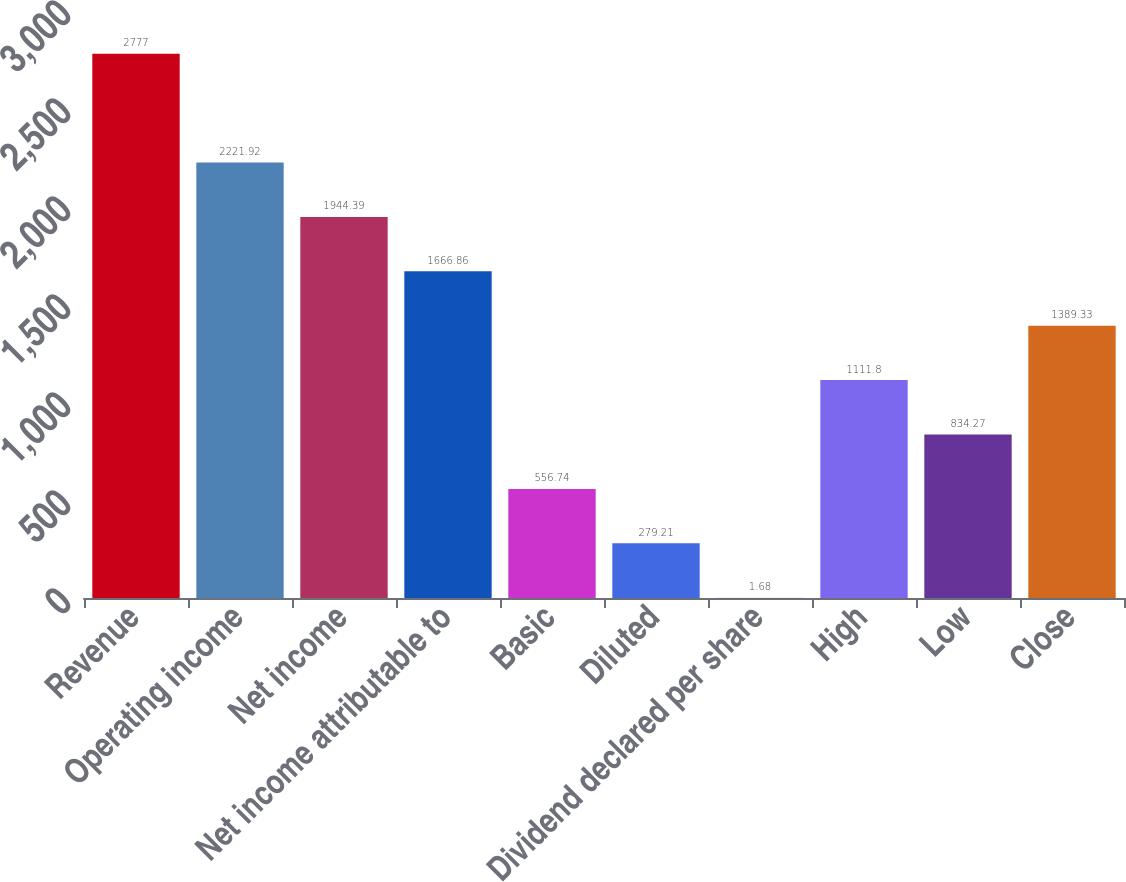Convert chart to OTSL. <chart><loc_0><loc_0><loc_500><loc_500><bar_chart><fcel>Revenue<fcel>Operating income<fcel>Net income<fcel>Net income attributable to<fcel>Basic<fcel>Diluted<fcel>Dividend declared per share<fcel>High<fcel>Low<fcel>Close<nl><fcel>2777<fcel>2221.92<fcel>1944.39<fcel>1666.86<fcel>556.74<fcel>279.21<fcel>1.68<fcel>1111.8<fcel>834.27<fcel>1389.33<nl></chart> 